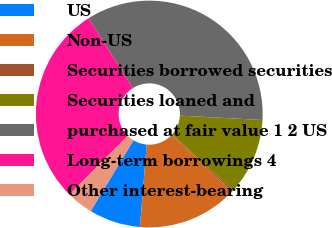<chart> <loc_0><loc_0><loc_500><loc_500><pie_chart><fcel>US<fcel>Non-US<fcel>Securities borrowed securities<fcel>Securities loaned and<fcel>purchased at fair value 1 2 US<fcel>Long-term borrowings 4<fcel>Other interest-bearing<nl><fcel>7.32%<fcel>14.36%<fcel>0.27%<fcel>10.84%<fcel>34.82%<fcel>28.59%<fcel>3.79%<nl></chart> 